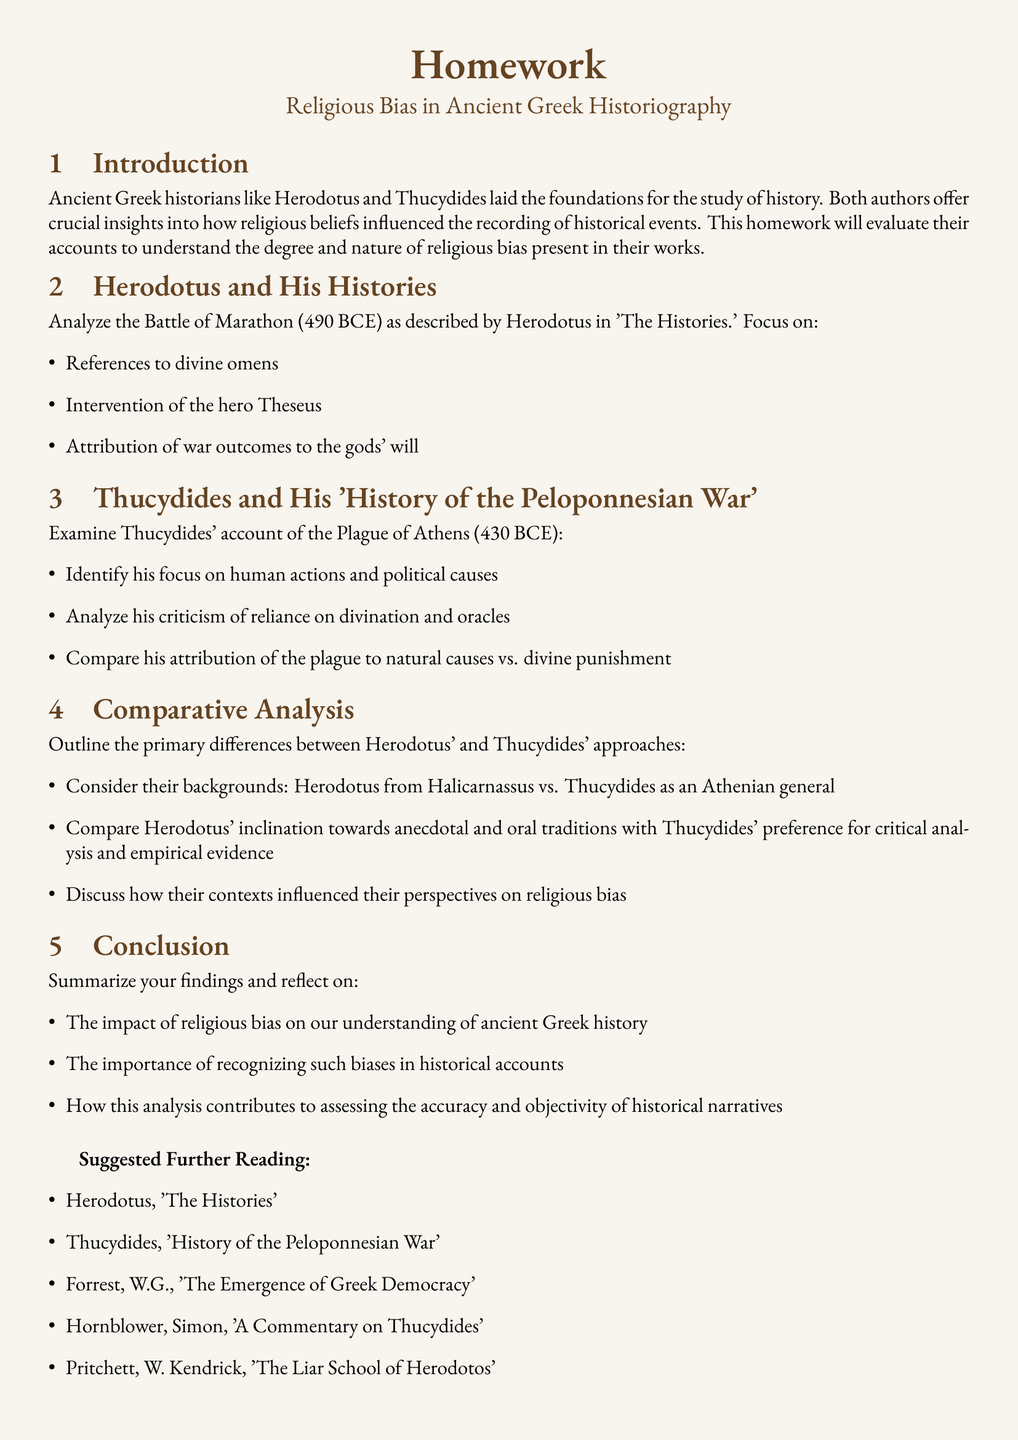What is the title of the homework? The title is stated in the document's heading section.
Answer: Religious Bias in Ancient Greek Historiography Who is the author of 'The Histories'? The document discusses Herodotus as the author of 'The Histories.'
Answer: Herodotus What year did the Battle of Marathon occur? The document specifies the year related to the Battle of Marathon.
Answer: 490 BCE What is the focus of Thucydides' examination regarding the Plague of Athens? The document outlines that Thucydides focuses on human actions and political causes.
Answer: Human actions and political causes Which hero is mentioned in relation to divine intervention in Herodotus' account? The document states a specific hero's involvement in the Battle of Marathon.
Answer: Theseus What type of analysis does Thucydides prefer over anecdotal traditions? The document contrasts Thucydides' analytical style with Herodotus' approach.
Answer: Critical analysis and empirical evidence In what year did the Plague of Athens occur? The document provides the specific year for the Plague of Athens.
Answer: 430 BCE What should be summarized in the conclusion section? The document specifies the findings and reflections as key components of the conclusion.
Answer: Findings and reflections 